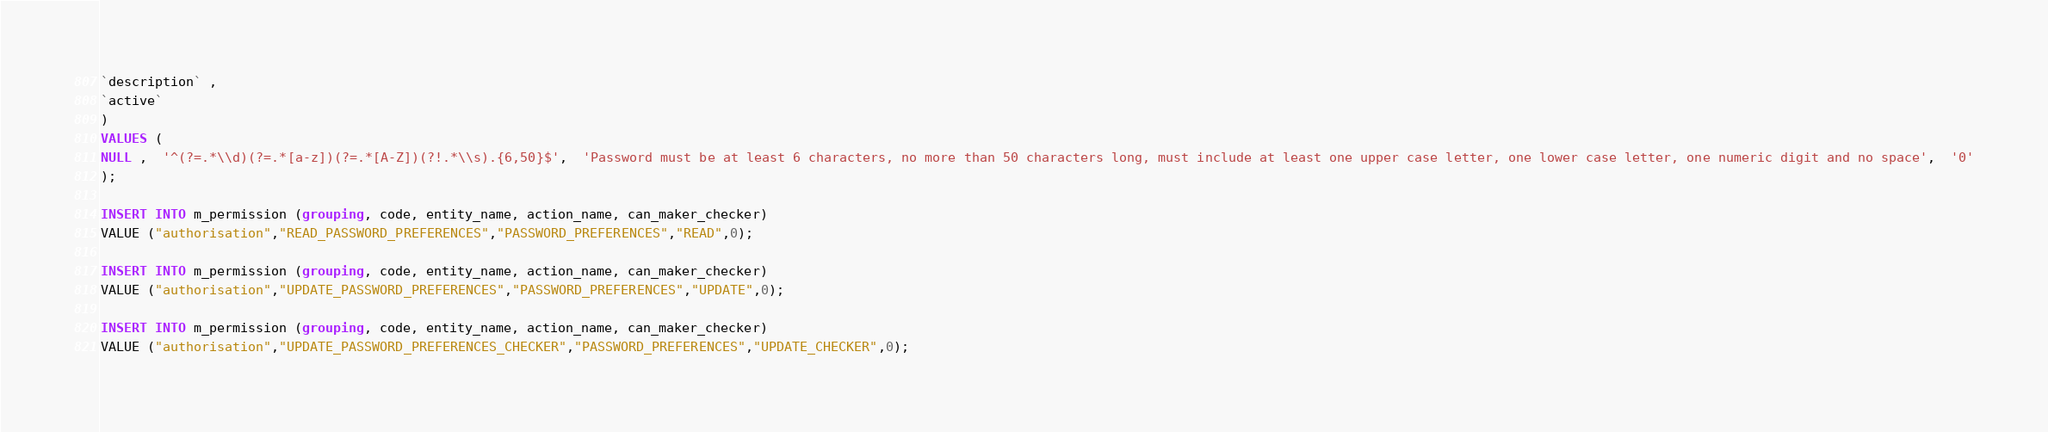Convert code to text. <code><loc_0><loc_0><loc_500><loc_500><_SQL_>`description` ,
`active`
)
VALUES (
NULL ,  '^(?=.*\\d)(?=.*[a-z])(?=.*[A-Z])(?!.*\\s).{6,50}$',  'Password must be at least 6 characters, no more than 50 characters long, must include at least one upper case letter, one lower case letter, one numeric digit and no space',  '0'
);

INSERT INTO m_permission (grouping, code, entity_name, action_name, can_maker_checker)
VALUE ("authorisation","READ_PASSWORD_PREFERENCES","PASSWORD_PREFERENCES","READ",0);

INSERT INTO m_permission (grouping, code, entity_name, action_name, can_maker_checker)
VALUE ("authorisation","UPDATE_PASSWORD_PREFERENCES","PASSWORD_PREFERENCES","UPDATE",0);

INSERT INTO m_permission (grouping, code, entity_name, action_name, can_maker_checker)
VALUE ("authorisation","UPDATE_PASSWORD_PREFERENCES_CHECKER","PASSWORD_PREFERENCES","UPDATE_CHECKER",0);





</code> 